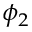Convert formula to latex. <formula><loc_0><loc_0><loc_500><loc_500>\phi _ { 2 }</formula> 